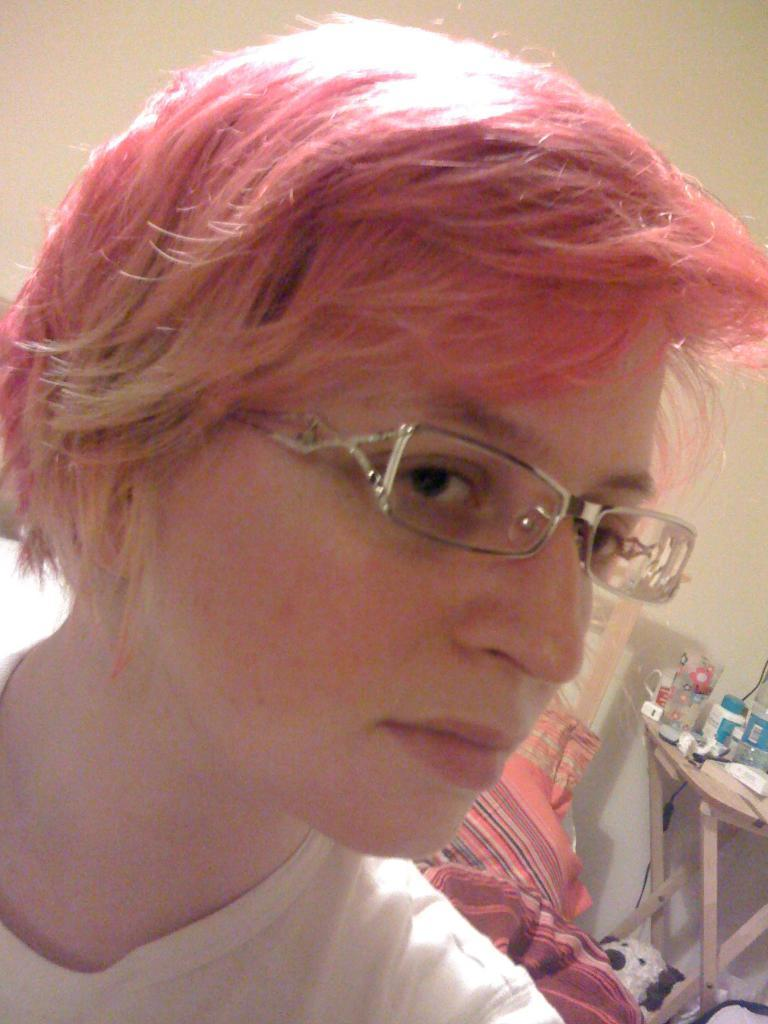What is a distinctive feature of the person in the image? The person in the image has red hair. What accessory is the person wearing? The person is wearing spectacles. What object can be seen in the image besides the person? There is a table in the image. What is on the table in the image? There are things on the table. What verse is the duck reciting in the image? There is no duck present in the image, and therefore no verse can be recited. 